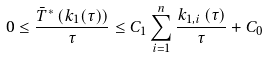<formula> <loc_0><loc_0><loc_500><loc_500>0 \leq \frac { \bar { T } ^ { * } \left ( k _ { 1 } ( \tau ) \right ) } { \tau } \leq C _ { 1 } \sum _ { i = 1 } ^ { n } \frac { k _ { 1 , i } \left ( \tau \right ) } { \tau } + C _ { 0 }</formula> 